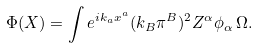Convert formula to latex. <formula><loc_0><loc_0><loc_500><loc_500>\Phi ( X ) = \int e ^ { i k _ { a } x ^ { a } } ( k _ { B } \pi ^ { B } ) ^ { 2 } Z ^ { \alpha } \phi _ { \alpha } \, \Omega .</formula> 